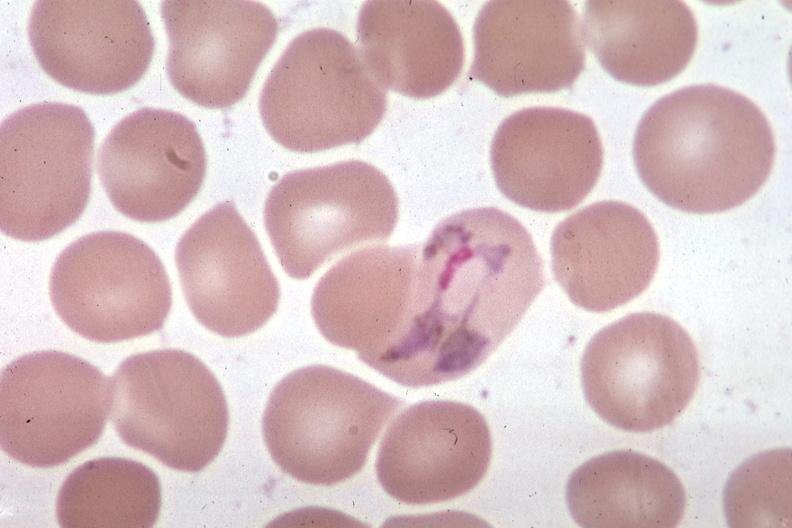does this image show wrights excellent?
Answer the question using a single word or phrase. Yes 